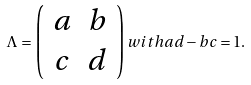Convert formula to latex. <formula><loc_0><loc_0><loc_500><loc_500>\Lambda = \left ( \begin{array} { c c } a & b \\ c & d \end{array} \right ) w i t h a d - b c = 1 .</formula> 